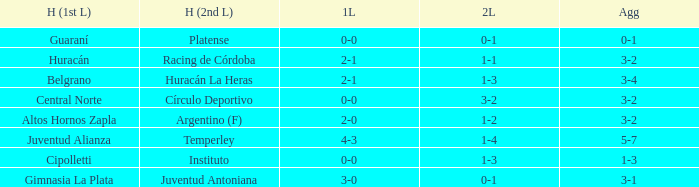Who played at home for the 2nd leg with a score of 1-2? Argentino (F). 